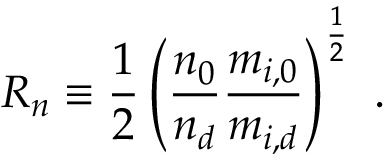Convert formula to latex. <formula><loc_0><loc_0><loc_500><loc_500>R _ { n } \equiv \frac { 1 } { 2 } \left ( \frac { n _ { 0 } } { n _ { d } } \frac { m _ { i , 0 } } { m _ { i , d } } \right ) ^ { \frac { 1 } { 2 } } \ .</formula> 